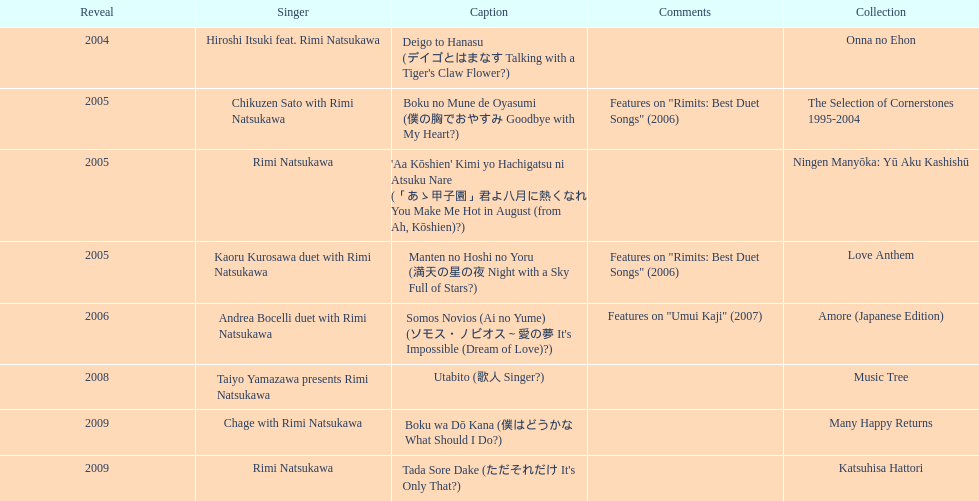What was the total number of appearances made by this artist in 2005, apart from this one? 3. 